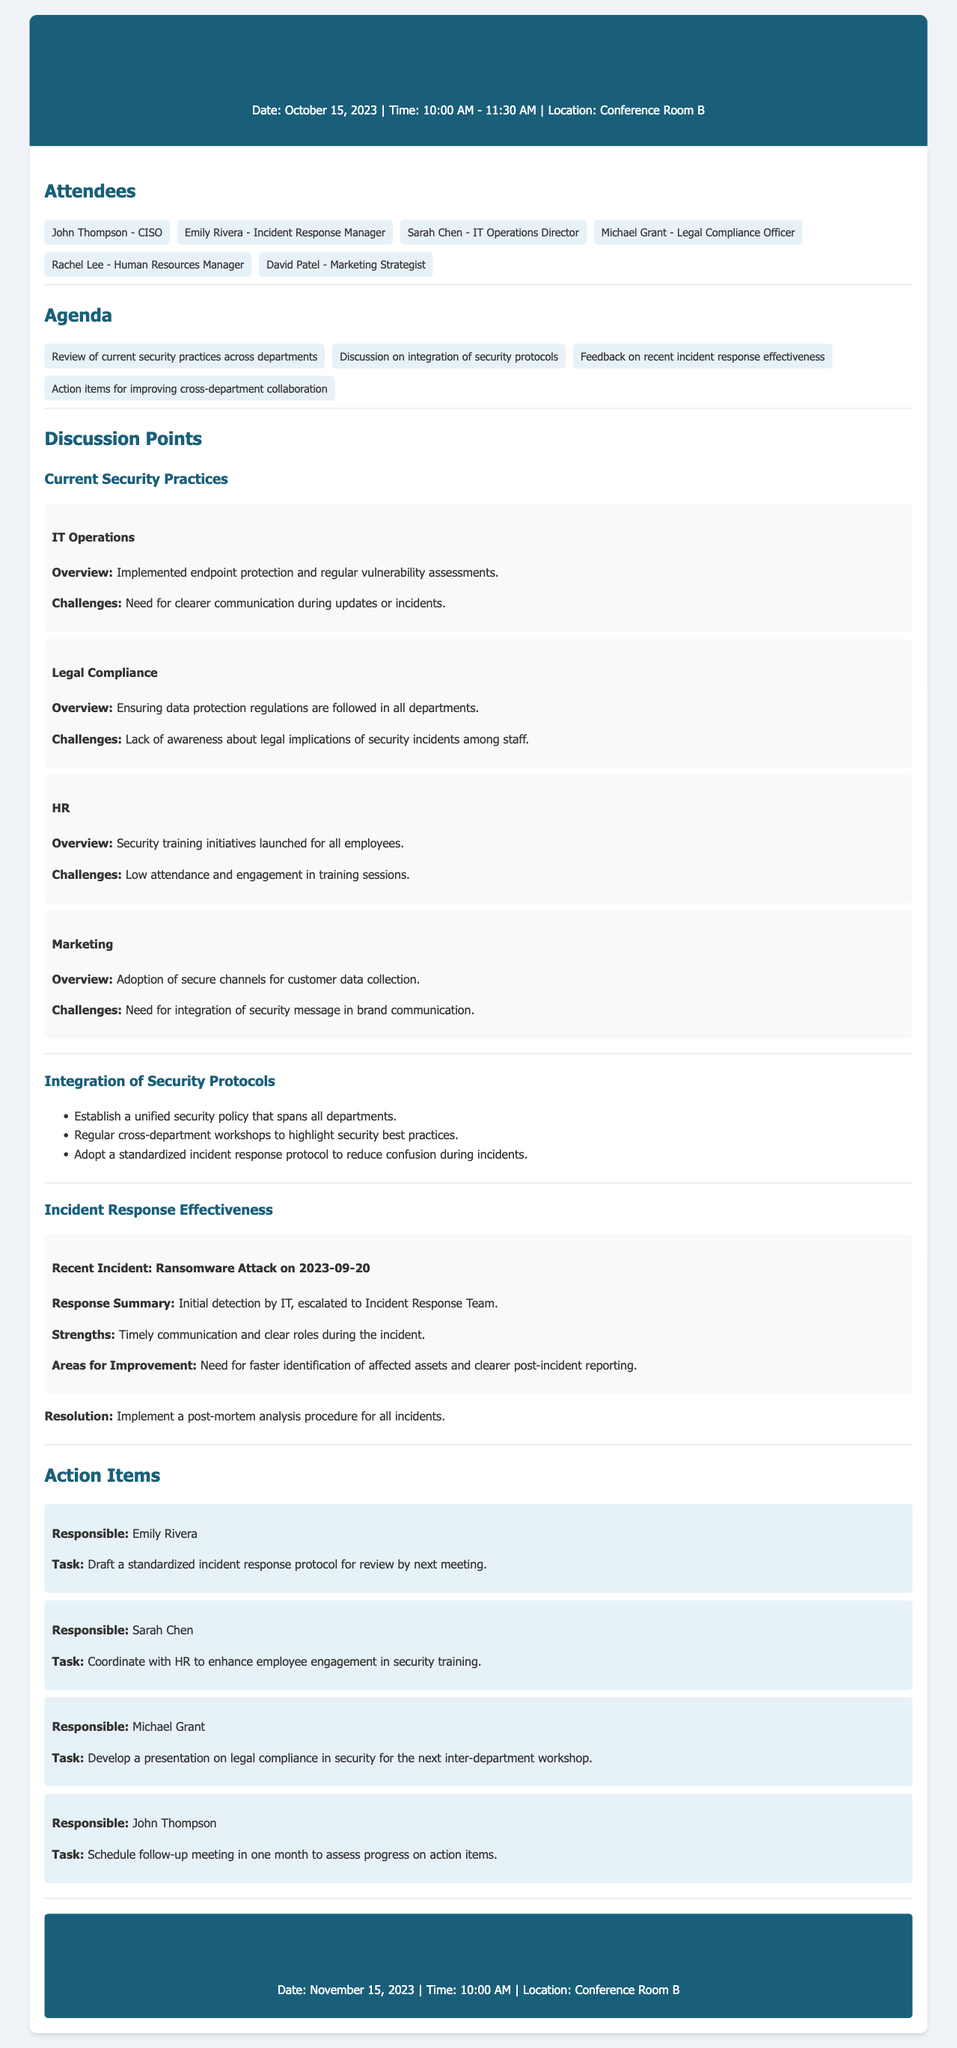what is the date of the meeting? The date of the meeting is stated in the header section of the document.
Answer: October 15, 2023 who is responsible for drafting a standardized incident response protocol? This information is located in the action items section detailing the tasks assigned to attendees.
Answer: Emily Rivera what was one of the strengths mentioned during the recent ransomware incident? This point is mentioned in the discussion of incident response effectiveness which summarizes the strengths observed during the incident.
Answer: Timely communication what is one action item assigned to Sarah Chen? This is specified in the action items section where responsibilities are outlined for each attendee.
Answer: Enhance employee engagement in security training how long is the next meeting scheduled after the current one? The next meeting date is mentioned in the next meeting section compared to the current meeting date.
Answer: One month 